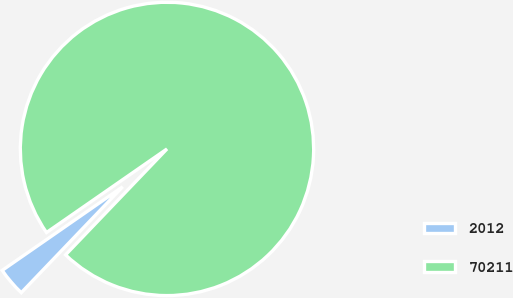Convert chart. <chart><loc_0><loc_0><loc_500><loc_500><pie_chart><fcel>2012<fcel>70211<nl><fcel>3.19%<fcel>96.81%<nl></chart> 